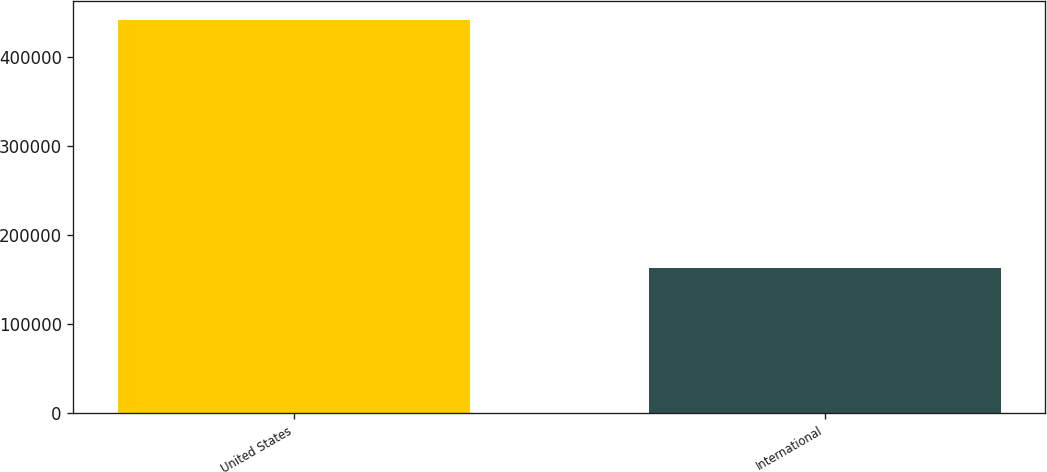Convert chart. <chart><loc_0><loc_0><loc_500><loc_500><bar_chart><fcel>United States<fcel>International<nl><fcel>441336<fcel>162424<nl></chart> 